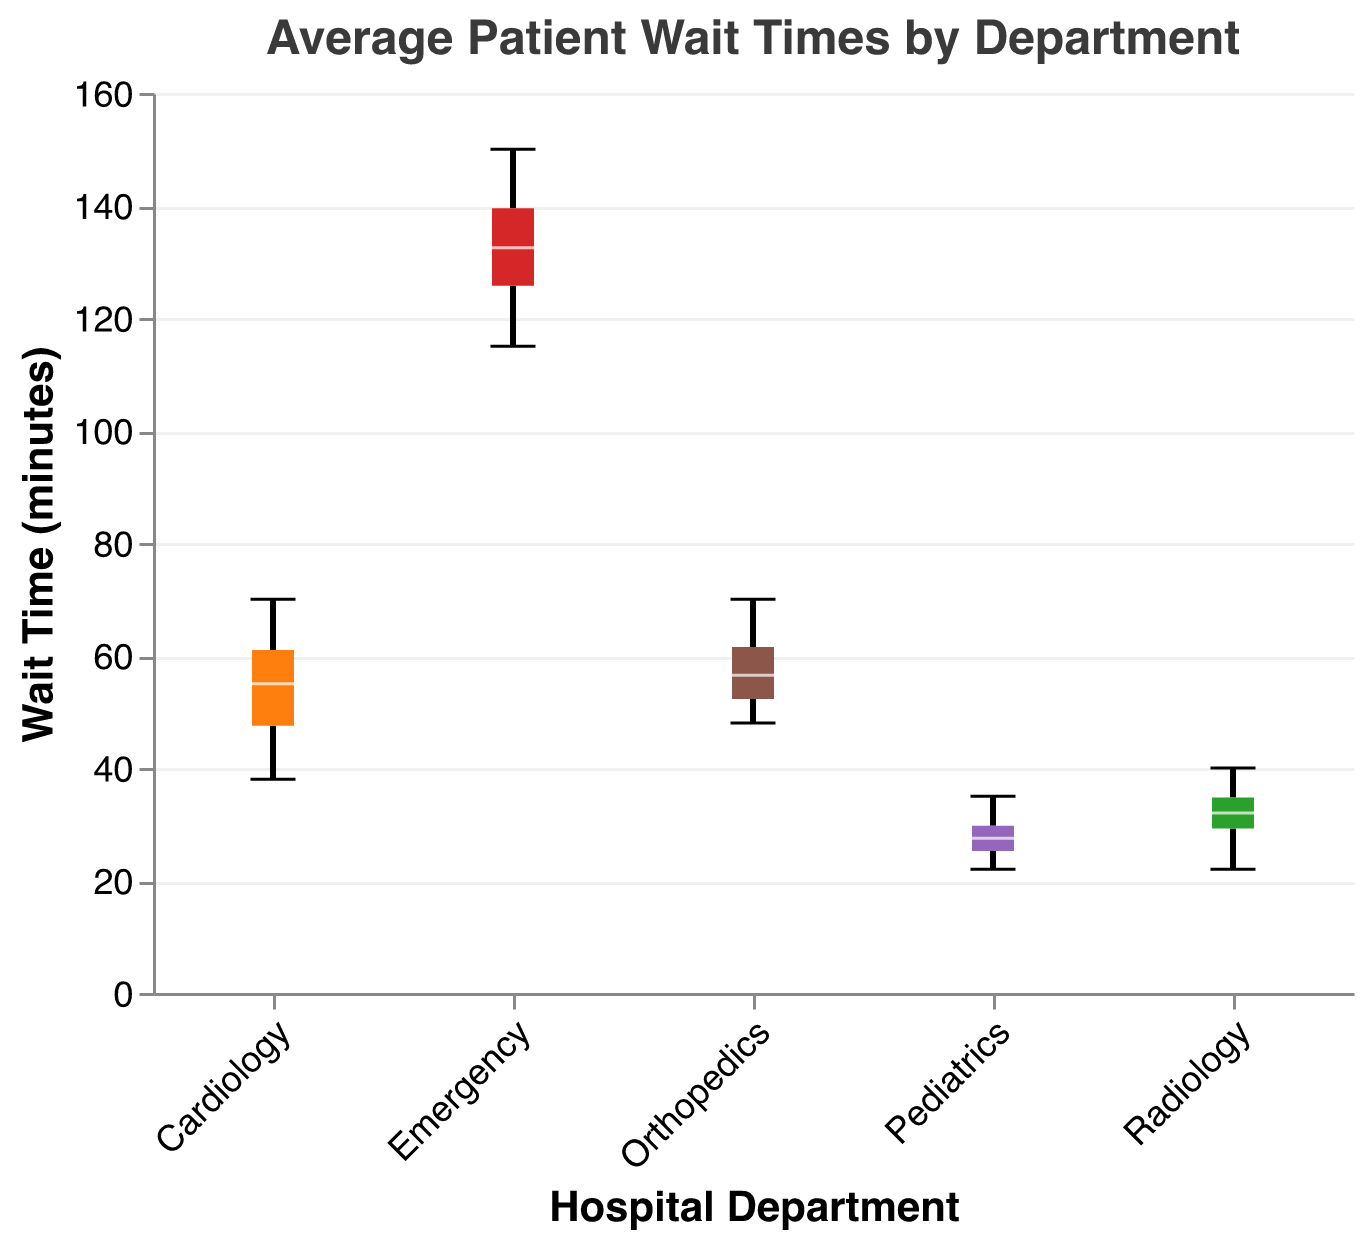What's the title of the plot? The title is usually written at the top of the plot, and it reads "Average Patient Wait Times by Department"
Answer: Average Patient Wait Times by Department Which department has the highest median wait time? The notched box plot visually indicates the median with a line in the middle of each box. The department with the highest median line is Emergency
Answer: Emergency How does the interquartile range (IQR) of Cardiologist compare to that of Radiology? The IQR is represented by the height of the box, which spans from the first quartile (Q1) to the third quartile (Q3). By visually comparing both boxes' heights, the IQR for Cardiology appears larger than Radiology
Answer: Cardiology has a larger IQR What's the median wait time in Pediatrics? The median wait time can be found at the line inside the box for the Pediatrics department. By examining the plot, the median line is approximately at 27 minutes
Answer: 27 minutes Which department shows the most variability in wait times? Variability can be gauged by the spread of the box plots and the extent of their whiskers. Emergency has the widest spread and longest whiskers, suggesting the most variability
Answer: Emergency Are there any outliers in the Radiology department? Outliers are typically represented as individual points outside the whiskers of the box plot. Radiology does not show any such points, meaning no outliers are present
Answer: No How does the median wait time in Orthopedics compare to Cardiology? By comparing the median lines of both departments' box plots, Orthopedics has a median line at around 55 minutes, while Cardiology's median is slightly higher, around 55 minutes as well
Answer: Orthopedics is slightly lower What is the maximum wait time recorded in the Orthopedics department? The maximum wait time is represented by the top whisker end for Orthopedics. It reaches approximately 70 minutes
Answer: 70 minutes Which department has the shortest average wait time, and what is it? Pediatrics has the overall shortest wait time, with a box plot that is lowest among all departments. The median for Pediatrics is approximately 27 minutes
Answer: Pediatrics, 27 minutes How do the wait times for the Emergency department compare to other departments? The Emergency department shows the highest wait times compared to all other departments, both in terms of median and the range (spread) of wait times
Answer: Emergency has the longest wait times 